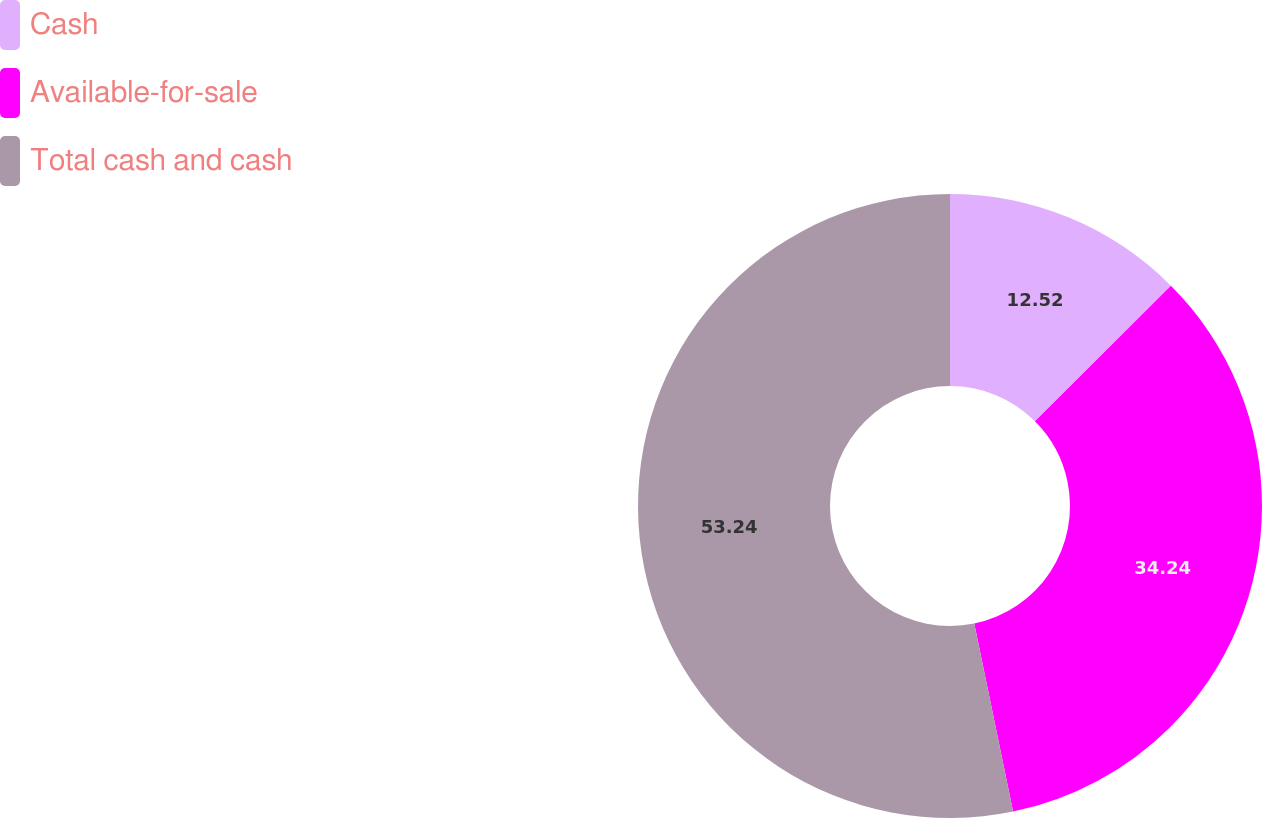Convert chart to OTSL. <chart><loc_0><loc_0><loc_500><loc_500><pie_chart><fcel>Cash<fcel>Available-for-sale<fcel>Total cash and cash<nl><fcel>12.52%<fcel>34.24%<fcel>53.24%<nl></chart> 